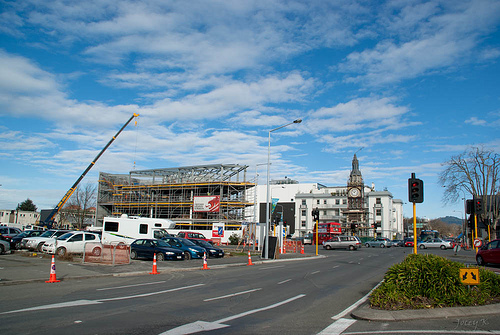<image>
Is the cone in front of the car? Yes. The cone is positioned in front of the car, appearing closer to the camera viewpoint. 